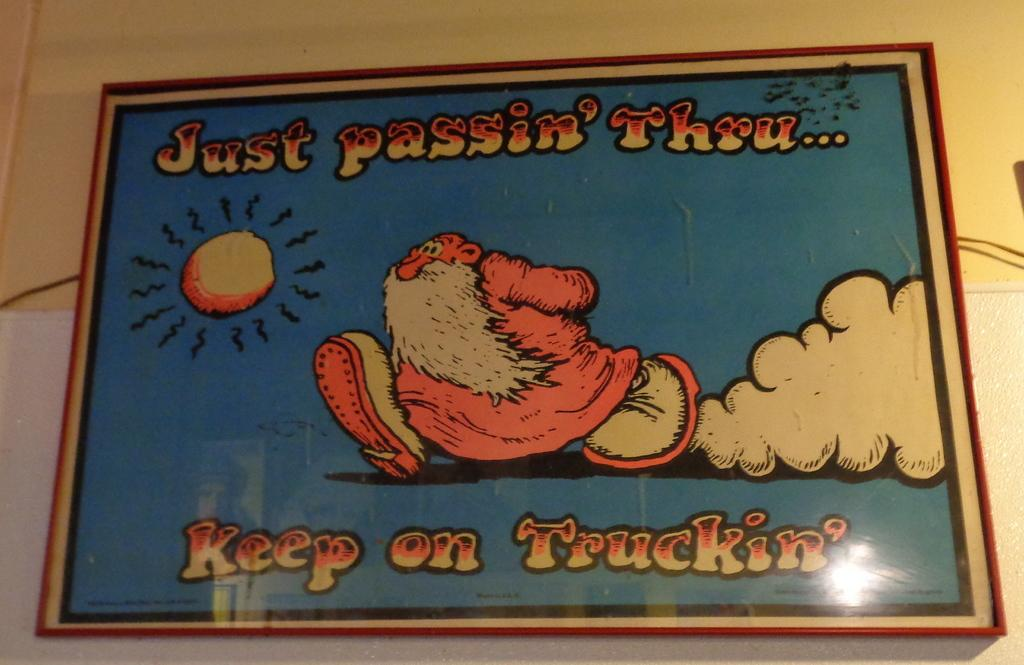Provide a one-sentence caption for the provided image. a poster that has a man on it with the wording just keep trucking thru. 